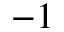<formula> <loc_0><loc_0><loc_500><loc_500>- 1</formula> 